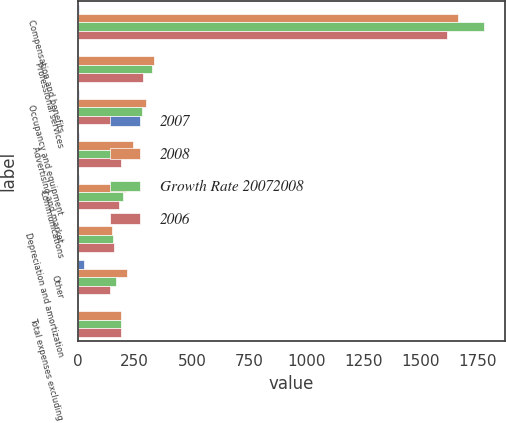Convert chart. <chart><loc_0><loc_0><loc_500><loc_500><stacked_bar_chart><ecel><fcel>Compensation and benefits<fcel>Professional services<fcel>Occupancy and equipment<fcel>Advertising and market<fcel>Communications<fcel>Depreciation and amortization<fcel>Other<fcel>Total expenses excluding<nl><fcel>2007<fcel>6<fcel>3<fcel>6<fcel>6<fcel>6<fcel>3<fcel>29<fcel>1<nl><fcel>2008<fcel>1667<fcel>334<fcel>299<fcel>243<fcel>211<fcel>152<fcel>216<fcel>189<nl><fcel>Growth Rate 20072008<fcel>1781<fcel>324<fcel>282<fcel>230<fcel>200<fcel>156<fcel>168<fcel>189<nl><fcel>2006<fcel>1619<fcel>285<fcel>260<fcel>189<fcel>180<fcel>157<fcel>143<fcel>189<nl></chart> 